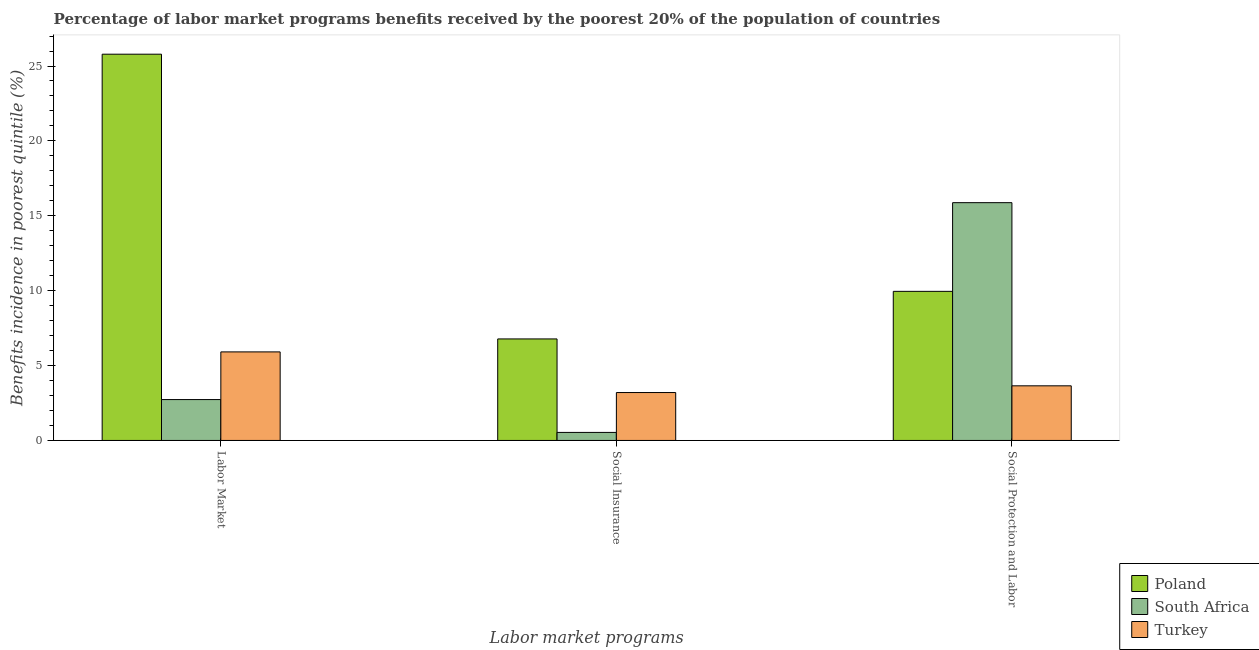How many groups of bars are there?
Offer a terse response. 3. How many bars are there on the 2nd tick from the left?
Ensure brevity in your answer.  3. How many bars are there on the 2nd tick from the right?
Offer a very short reply. 3. What is the label of the 1st group of bars from the left?
Offer a very short reply. Labor Market. What is the percentage of benefits received due to labor market programs in Poland?
Your response must be concise. 25.79. Across all countries, what is the maximum percentage of benefits received due to labor market programs?
Keep it short and to the point. 25.79. Across all countries, what is the minimum percentage of benefits received due to social insurance programs?
Provide a succinct answer. 0.54. In which country was the percentage of benefits received due to social protection programs maximum?
Provide a short and direct response. South Africa. In which country was the percentage of benefits received due to labor market programs minimum?
Your answer should be compact. South Africa. What is the total percentage of benefits received due to labor market programs in the graph?
Keep it short and to the point. 34.43. What is the difference between the percentage of benefits received due to social insurance programs in Turkey and that in South Africa?
Your response must be concise. 2.66. What is the difference between the percentage of benefits received due to social protection programs in Turkey and the percentage of benefits received due to social insurance programs in Poland?
Your answer should be compact. -3.13. What is the average percentage of benefits received due to social protection programs per country?
Your response must be concise. 9.83. What is the difference between the percentage of benefits received due to social insurance programs and percentage of benefits received due to social protection programs in Turkey?
Ensure brevity in your answer.  -0.45. In how many countries, is the percentage of benefits received due to social protection programs greater than 2 %?
Give a very brief answer. 3. What is the ratio of the percentage of benefits received due to social protection programs in South Africa to that in Poland?
Provide a succinct answer. 1.59. Is the difference between the percentage of benefits received due to labor market programs in Turkey and Poland greater than the difference between the percentage of benefits received due to social protection programs in Turkey and Poland?
Ensure brevity in your answer.  No. What is the difference between the highest and the second highest percentage of benefits received due to labor market programs?
Your response must be concise. 19.88. What is the difference between the highest and the lowest percentage of benefits received due to social protection programs?
Give a very brief answer. 12.23. What does the 2nd bar from the left in Labor Market represents?
Make the answer very short. South Africa. How many bars are there?
Your response must be concise. 9. Are all the bars in the graph horizontal?
Your answer should be very brief. No. Does the graph contain any zero values?
Your answer should be compact. No. What is the title of the graph?
Your answer should be very brief. Percentage of labor market programs benefits received by the poorest 20% of the population of countries. Does "Hungary" appear as one of the legend labels in the graph?
Provide a succinct answer. No. What is the label or title of the X-axis?
Offer a very short reply. Labor market programs. What is the label or title of the Y-axis?
Keep it short and to the point. Benefits incidence in poorest quintile (%). What is the Benefits incidence in poorest quintile (%) of Poland in Labor Market?
Your answer should be very brief. 25.79. What is the Benefits incidence in poorest quintile (%) in South Africa in Labor Market?
Make the answer very short. 2.73. What is the Benefits incidence in poorest quintile (%) in Turkey in Labor Market?
Keep it short and to the point. 5.91. What is the Benefits incidence in poorest quintile (%) in Poland in Social Insurance?
Make the answer very short. 6.78. What is the Benefits incidence in poorest quintile (%) of South Africa in Social Insurance?
Provide a succinct answer. 0.54. What is the Benefits incidence in poorest quintile (%) of Turkey in Social Insurance?
Make the answer very short. 3.2. What is the Benefits incidence in poorest quintile (%) in Poland in Social Protection and Labor?
Your response must be concise. 9.96. What is the Benefits incidence in poorest quintile (%) of South Africa in Social Protection and Labor?
Offer a terse response. 15.88. What is the Benefits incidence in poorest quintile (%) in Turkey in Social Protection and Labor?
Your answer should be very brief. 3.65. Across all Labor market programs, what is the maximum Benefits incidence in poorest quintile (%) in Poland?
Give a very brief answer. 25.79. Across all Labor market programs, what is the maximum Benefits incidence in poorest quintile (%) of South Africa?
Your response must be concise. 15.88. Across all Labor market programs, what is the maximum Benefits incidence in poorest quintile (%) in Turkey?
Offer a very short reply. 5.91. Across all Labor market programs, what is the minimum Benefits incidence in poorest quintile (%) in Poland?
Your response must be concise. 6.78. Across all Labor market programs, what is the minimum Benefits incidence in poorest quintile (%) in South Africa?
Your response must be concise. 0.54. Across all Labor market programs, what is the minimum Benefits incidence in poorest quintile (%) of Turkey?
Give a very brief answer. 3.2. What is the total Benefits incidence in poorest quintile (%) of Poland in the graph?
Your answer should be compact. 42.52. What is the total Benefits incidence in poorest quintile (%) of South Africa in the graph?
Offer a terse response. 19.14. What is the total Benefits incidence in poorest quintile (%) in Turkey in the graph?
Keep it short and to the point. 12.76. What is the difference between the Benefits incidence in poorest quintile (%) in Poland in Labor Market and that in Social Insurance?
Ensure brevity in your answer.  19.01. What is the difference between the Benefits incidence in poorest quintile (%) in South Africa in Labor Market and that in Social Insurance?
Give a very brief answer. 2.19. What is the difference between the Benefits incidence in poorest quintile (%) in Turkey in Labor Market and that in Social Insurance?
Your answer should be compact. 2.71. What is the difference between the Benefits incidence in poorest quintile (%) of Poland in Labor Market and that in Social Protection and Labor?
Give a very brief answer. 15.83. What is the difference between the Benefits incidence in poorest quintile (%) of South Africa in Labor Market and that in Social Protection and Labor?
Keep it short and to the point. -13.15. What is the difference between the Benefits incidence in poorest quintile (%) of Turkey in Labor Market and that in Social Protection and Labor?
Your answer should be compact. 2.27. What is the difference between the Benefits incidence in poorest quintile (%) in Poland in Social Insurance and that in Social Protection and Labor?
Your response must be concise. -3.18. What is the difference between the Benefits incidence in poorest quintile (%) of South Africa in Social Insurance and that in Social Protection and Labor?
Keep it short and to the point. -15.34. What is the difference between the Benefits incidence in poorest quintile (%) of Turkey in Social Insurance and that in Social Protection and Labor?
Keep it short and to the point. -0.45. What is the difference between the Benefits incidence in poorest quintile (%) of Poland in Labor Market and the Benefits incidence in poorest quintile (%) of South Africa in Social Insurance?
Your answer should be compact. 25.25. What is the difference between the Benefits incidence in poorest quintile (%) of Poland in Labor Market and the Benefits incidence in poorest quintile (%) of Turkey in Social Insurance?
Your response must be concise. 22.59. What is the difference between the Benefits incidence in poorest quintile (%) in South Africa in Labor Market and the Benefits incidence in poorest quintile (%) in Turkey in Social Insurance?
Make the answer very short. -0.47. What is the difference between the Benefits incidence in poorest quintile (%) of Poland in Labor Market and the Benefits incidence in poorest quintile (%) of South Africa in Social Protection and Labor?
Give a very brief answer. 9.91. What is the difference between the Benefits incidence in poorest quintile (%) in Poland in Labor Market and the Benefits incidence in poorest quintile (%) in Turkey in Social Protection and Labor?
Offer a terse response. 22.14. What is the difference between the Benefits incidence in poorest quintile (%) of South Africa in Labor Market and the Benefits incidence in poorest quintile (%) of Turkey in Social Protection and Labor?
Give a very brief answer. -0.92. What is the difference between the Benefits incidence in poorest quintile (%) of Poland in Social Insurance and the Benefits incidence in poorest quintile (%) of South Africa in Social Protection and Labor?
Ensure brevity in your answer.  -9.1. What is the difference between the Benefits incidence in poorest quintile (%) in Poland in Social Insurance and the Benefits incidence in poorest quintile (%) in Turkey in Social Protection and Labor?
Ensure brevity in your answer.  3.13. What is the difference between the Benefits incidence in poorest quintile (%) in South Africa in Social Insurance and the Benefits incidence in poorest quintile (%) in Turkey in Social Protection and Labor?
Provide a succinct answer. -3.11. What is the average Benefits incidence in poorest quintile (%) of Poland per Labor market programs?
Provide a succinct answer. 14.17. What is the average Benefits incidence in poorest quintile (%) of South Africa per Labor market programs?
Keep it short and to the point. 6.38. What is the average Benefits incidence in poorest quintile (%) of Turkey per Labor market programs?
Give a very brief answer. 4.25. What is the difference between the Benefits incidence in poorest quintile (%) in Poland and Benefits incidence in poorest quintile (%) in South Africa in Labor Market?
Provide a short and direct response. 23.06. What is the difference between the Benefits incidence in poorest quintile (%) of Poland and Benefits incidence in poorest quintile (%) of Turkey in Labor Market?
Make the answer very short. 19.88. What is the difference between the Benefits incidence in poorest quintile (%) in South Africa and Benefits incidence in poorest quintile (%) in Turkey in Labor Market?
Provide a short and direct response. -3.18. What is the difference between the Benefits incidence in poorest quintile (%) in Poland and Benefits incidence in poorest quintile (%) in South Africa in Social Insurance?
Offer a very short reply. 6.24. What is the difference between the Benefits incidence in poorest quintile (%) in Poland and Benefits incidence in poorest quintile (%) in Turkey in Social Insurance?
Give a very brief answer. 3.58. What is the difference between the Benefits incidence in poorest quintile (%) in South Africa and Benefits incidence in poorest quintile (%) in Turkey in Social Insurance?
Your answer should be compact. -2.66. What is the difference between the Benefits incidence in poorest quintile (%) of Poland and Benefits incidence in poorest quintile (%) of South Africa in Social Protection and Labor?
Give a very brief answer. -5.92. What is the difference between the Benefits incidence in poorest quintile (%) in Poland and Benefits incidence in poorest quintile (%) in Turkey in Social Protection and Labor?
Offer a very short reply. 6.31. What is the difference between the Benefits incidence in poorest quintile (%) in South Africa and Benefits incidence in poorest quintile (%) in Turkey in Social Protection and Labor?
Provide a short and direct response. 12.23. What is the ratio of the Benefits incidence in poorest quintile (%) in Poland in Labor Market to that in Social Insurance?
Your answer should be very brief. 3.8. What is the ratio of the Benefits incidence in poorest quintile (%) of South Africa in Labor Market to that in Social Insurance?
Your answer should be compact. 5.09. What is the ratio of the Benefits incidence in poorest quintile (%) of Turkey in Labor Market to that in Social Insurance?
Ensure brevity in your answer.  1.85. What is the ratio of the Benefits incidence in poorest quintile (%) in Poland in Labor Market to that in Social Protection and Labor?
Your answer should be compact. 2.59. What is the ratio of the Benefits incidence in poorest quintile (%) of South Africa in Labor Market to that in Social Protection and Labor?
Offer a very short reply. 0.17. What is the ratio of the Benefits incidence in poorest quintile (%) of Turkey in Labor Market to that in Social Protection and Labor?
Provide a succinct answer. 1.62. What is the ratio of the Benefits incidence in poorest quintile (%) of Poland in Social Insurance to that in Social Protection and Labor?
Your answer should be very brief. 0.68. What is the ratio of the Benefits incidence in poorest quintile (%) in South Africa in Social Insurance to that in Social Protection and Labor?
Your answer should be compact. 0.03. What is the ratio of the Benefits incidence in poorest quintile (%) in Turkey in Social Insurance to that in Social Protection and Labor?
Keep it short and to the point. 0.88. What is the difference between the highest and the second highest Benefits incidence in poorest quintile (%) in Poland?
Your answer should be compact. 15.83. What is the difference between the highest and the second highest Benefits incidence in poorest quintile (%) of South Africa?
Ensure brevity in your answer.  13.15. What is the difference between the highest and the second highest Benefits incidence in poorest quintile (%) in Turkey?
Give a very brief answer. 2.27. What is the difference between the highest and the lowest Benefits incidence in poorest quintile (%) of Poland?
Your answer should be very brief. 19.01. What is the difference between the highest and the lowest Benefits incidence in poorest quintile (%) of South Africa?
Your answer should be compact. 15.34. What is the difference between the highest and the lowest Benefits incidence in poorest quintile (%) in Turkey?
Make the answer very short. 2.71. 